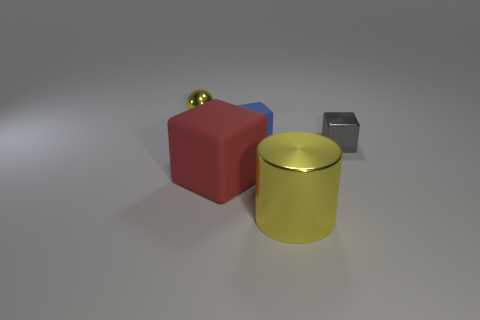How many gray things are either metal things or large matte blocks?
Offer a terse response. 1. Do the tiny gray cube and the large thing that is to the left of the blue matte block have the same material?
Provide a succinct answer. No. Are there an equal number of tiny rubber blocks that are in front of the blue matte thing and metallic objects in front of the small yellow object?
Your answer should be very brief. No. Is the size of the metal block the same as the yellow metallic thing that is in front of the red cube?
Your answer should be compact. No. Is the number of metal spheres behind the tiny gray metallic object greater than the number of cyan metal cylinders?
Your response must be concise. Yes. How many other metal balls have the same size as the yellow ball?
Ensure brevity in your answer.  0. There is a yellow metal thing that is on the left side of the small matte block; does it have the same size as the yellow metallic thing in front of the blue object?
Give a very brief answer. No. Is the number of balls in front of the large rubber block greater than the number of big blocks that are behind the tiny blue rubber cube?
Your response must be concise. No. What number of blue matte objects have the same shape as the gray metallic thing?
Ensure brevity in your answer.  1. What is the material of the cylinder that is the same size as the red cube?
Provide a succinct answer. Metal. 